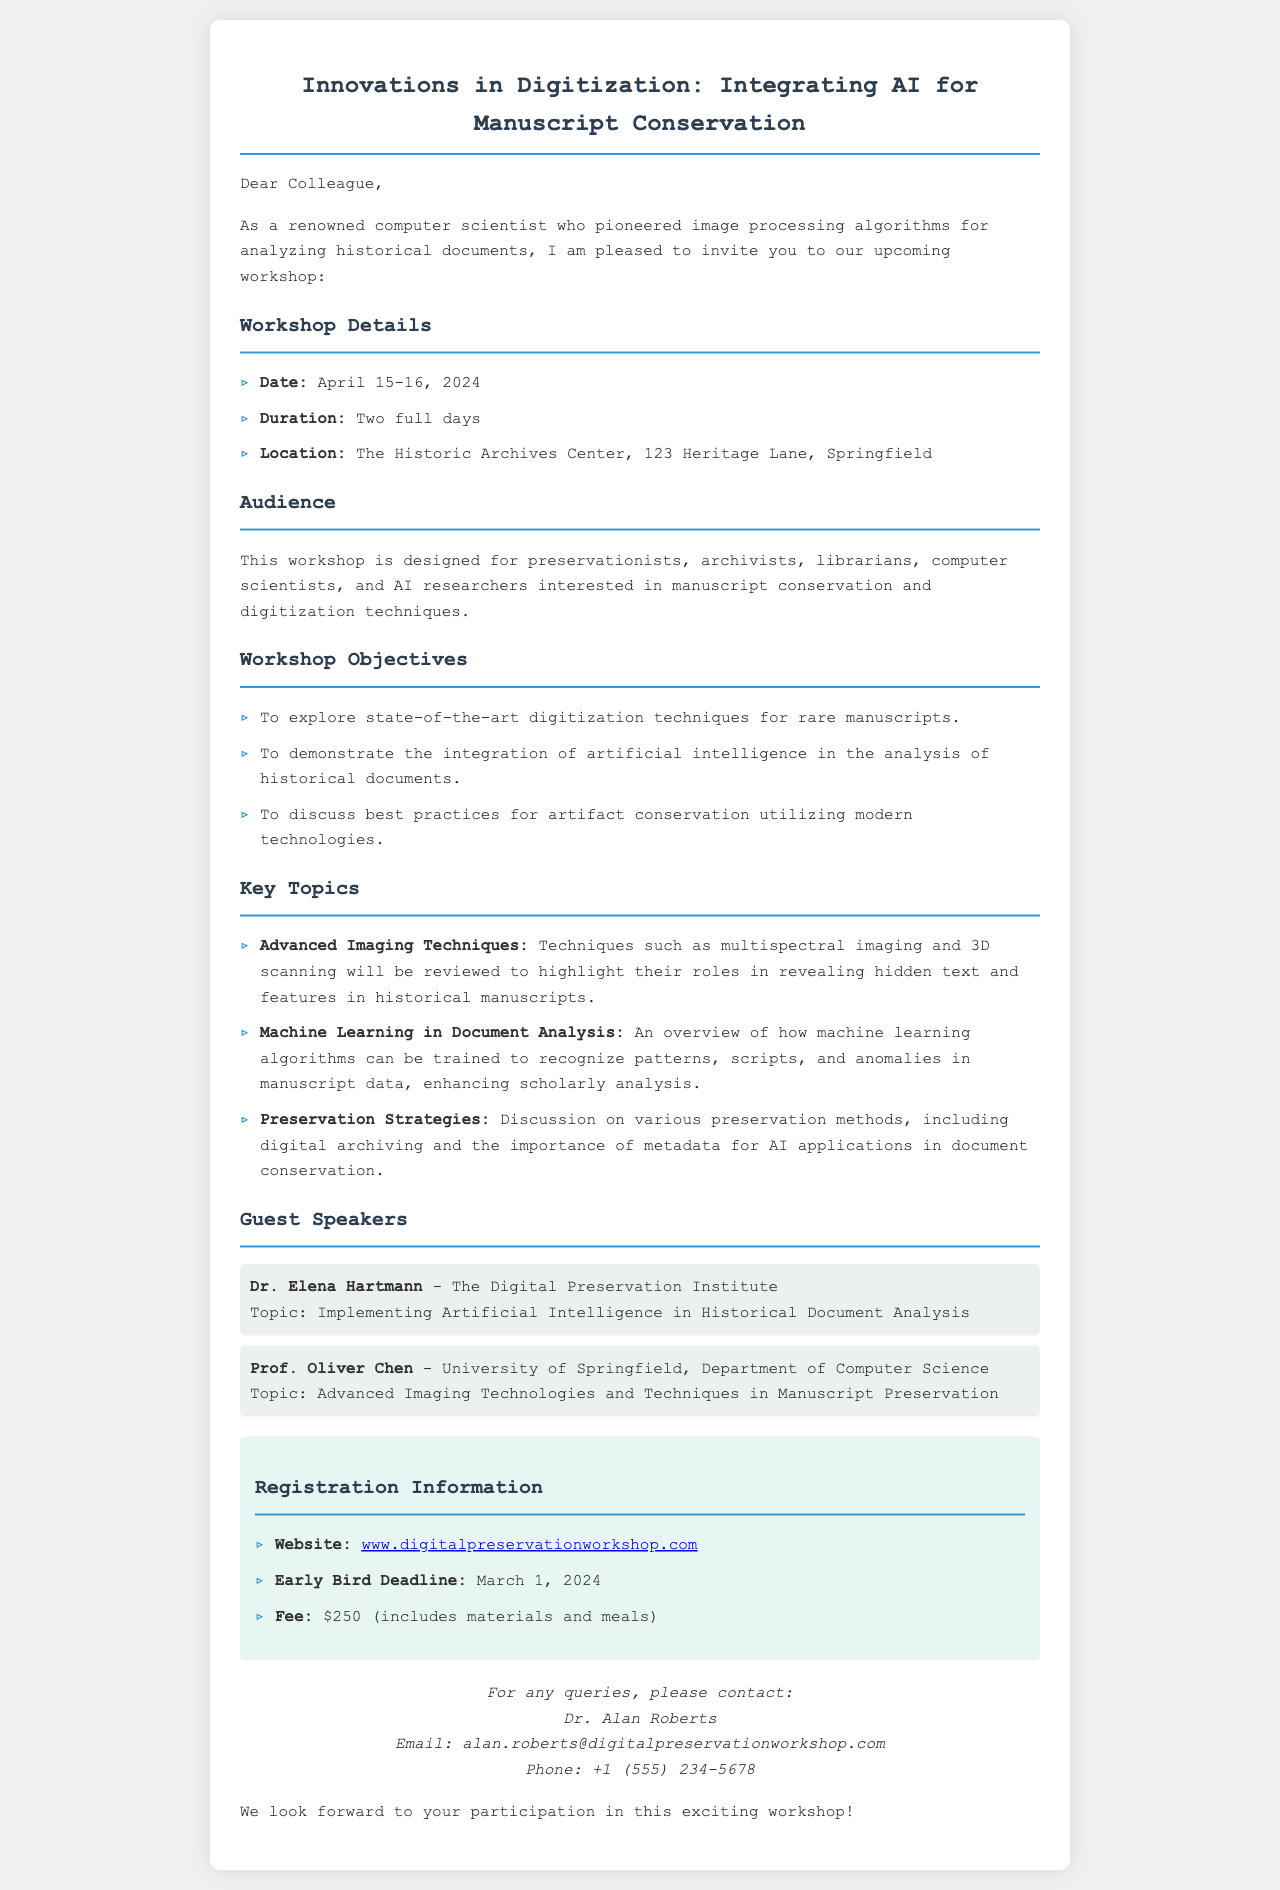What are the workshop dates? The workshop dates are clearly listed in the document.
Answer: April 15-16, 2024 Who is one of the guest speakers? The guest speakers are mentioned under a specific section in the document, highlighting their names and institutions.
Answer: Dr. Elena Hartmann What is the early bird registration deadline? The deadline information is provided in the registration section of the document.
Answer: March 1, 2024 What is the registration fee? The fee is stated explicitly in the registration information.
Answer: $250 What is one of the topics discussed in the workshop? Specific topics are listed under the "Key Topics" section of the document.
Answer: Advanced Imaging Techniques How many days will the workshop last? The duration of the workshop is mentioned at the beginning of the details section.
Answer: Two full days What is the location of the workshop? The location is provided with an address in the document.
Answer: The Historic Archives Center, 123 Heritage Lane, Springfield What type of audience is this workshop designed for? The audience type is outlined in a dedicated section within the document.
Answer: Preservationists, archivists, librarians, computer scientists, and AI researchers Who should be contacted for queries? The contact person is provided at the end of the document.
Answer: Dr. Alan Roberts 